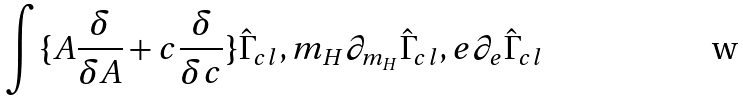<formula> <loc_0><loc_0><loc_500><loc_500>\int \{ A \frac { \delta } { \delta A } + c \frac { \delta } { \delta c } \} \hat { \Gamma } _ { c l } , m _ { H } \partial _ { m _ { H } } \hat { \Gamma } _ { c l } , e \partial _ { e } \hat { \Gamma } _ { c l }</formula> 